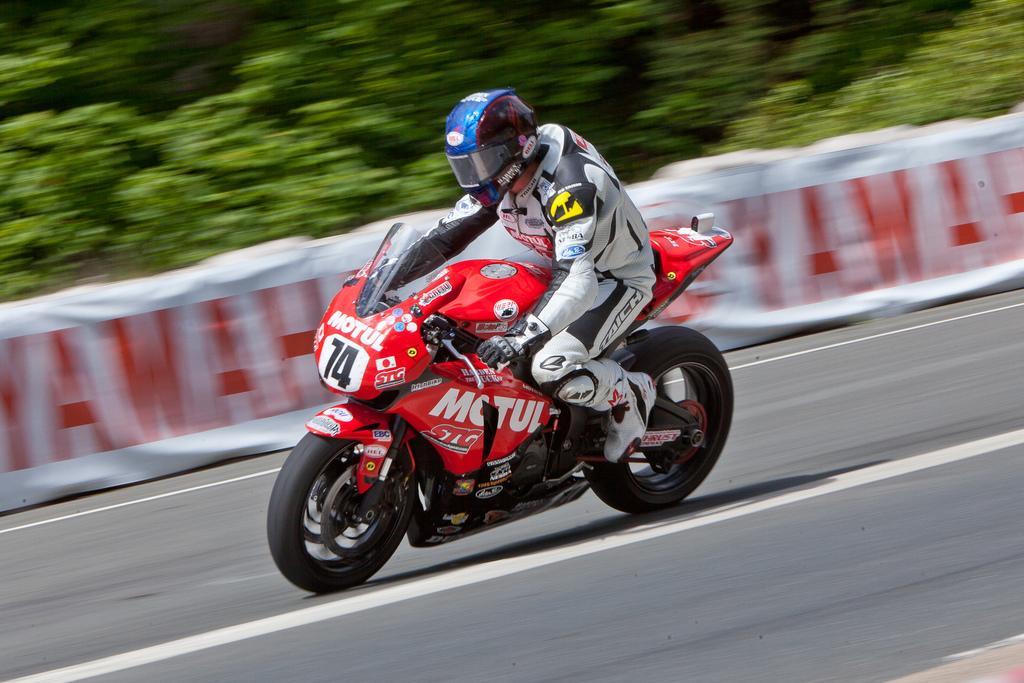Can you describe this image briefly? In this image we can see a person wearing dress, clothes, gloves and shoes is riding the red color bike on the road. The background of the image is blurred, we can see the banners and trees. 